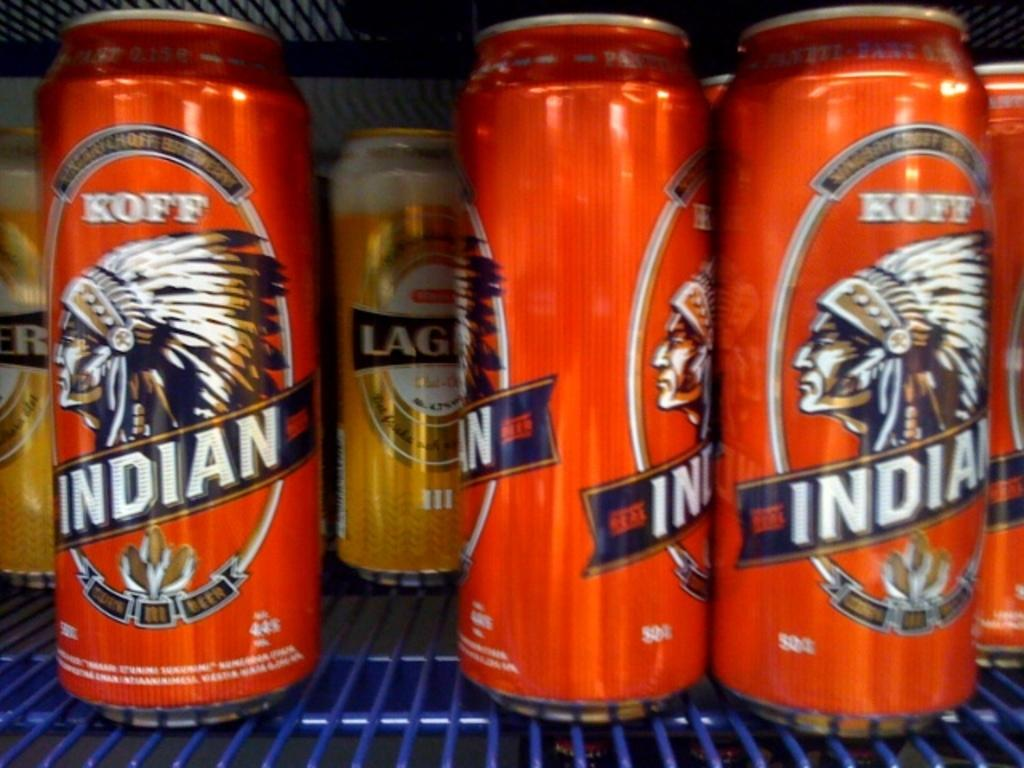<image>
Summarize the visual content of the image. A cooler shelf with several drinks in it labeled Indian. 